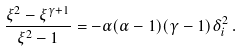<formula> <loc_0><loc_0><loc_500><loc_500>\frac { \xi ^ { 2 } - \xi ^ { \gamma + 1 } } { \xi ^ { 2 } - 1 } = - \alpha ( \alpha - 1 ) ( \gamma - 1 ) \delta _ { i } ^ { 2 } \, .</formula> 